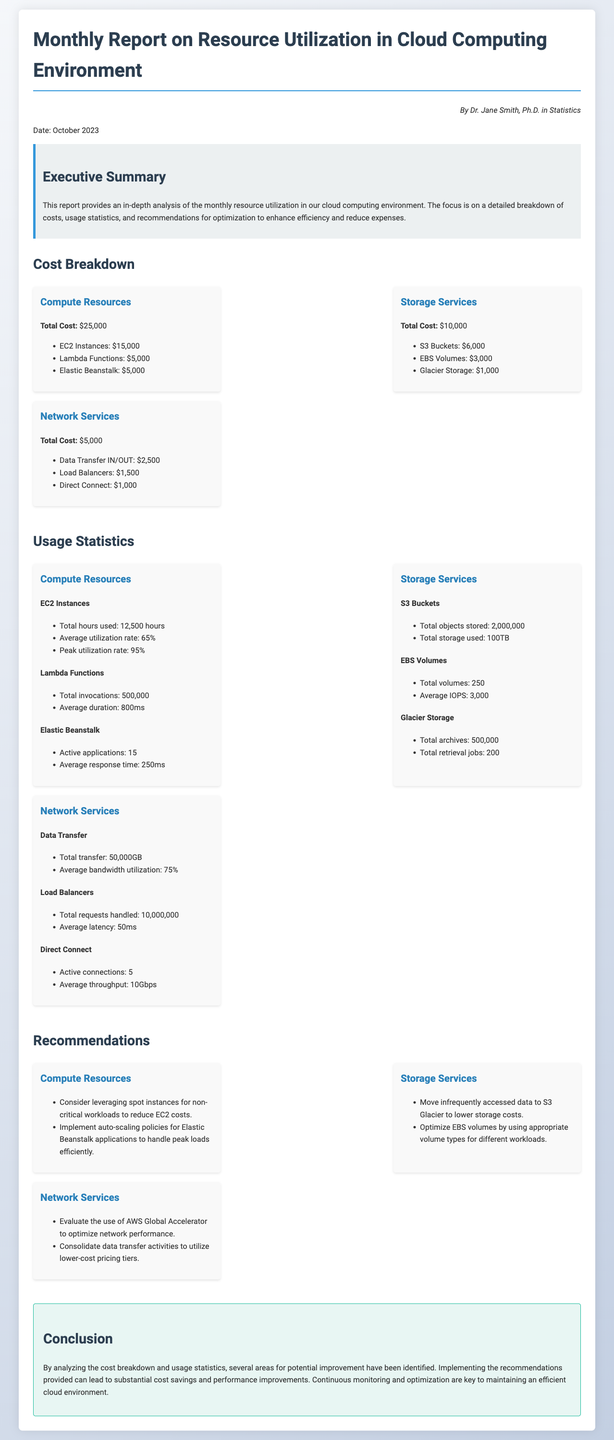What is the total cost for compute resources? The total cost for compute resources is explicitly stated in the document.
Answer: $25,000 What is the average utilization rate for EC2 instances? The average utilization rate is provided in the usage statistics section of the document.
Answer: 65% How many total archives are stored in Glacier? The total archives in Glacier is specified in the usage statistics section.
Answer: 500,000 What is one recommendation for storage services? The recommendations for storage services include specific suggestions provided in their respective section.
Answer: Move infrequently accessed data to S3 Glacier to lower storage costs What is the total transfer amount for network services? The total transfer amount can be found in the network services usage statistics.
Answer: 50,000GB 